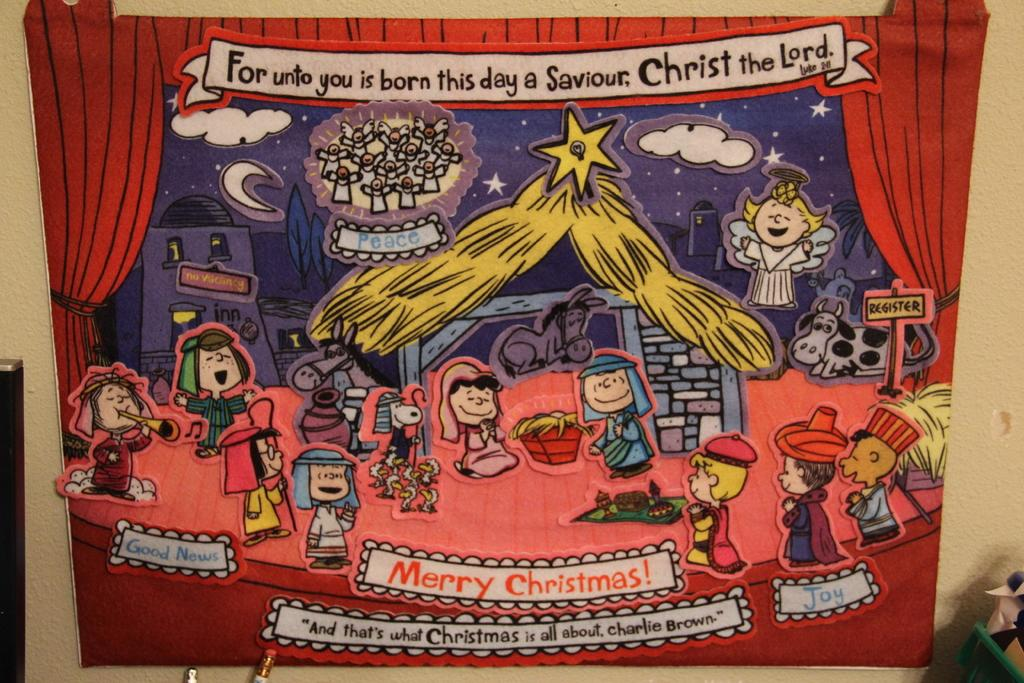<image>
Offer a succinct explanation of the picture presented. The Peanuts gang on stage with a Merry Christmas banner. 